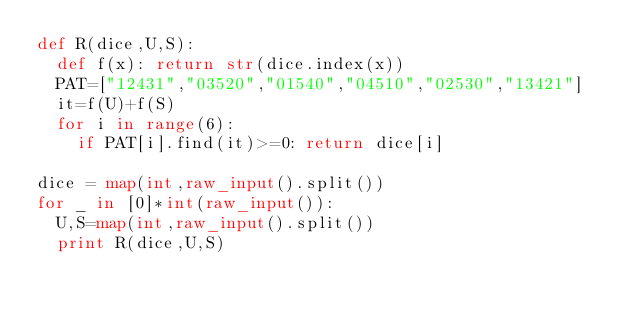<code> <loc_0><loc_0><loc_500><loc_500><_Python_>def R(dice,U,S):
  def f(x): return str(dice.index(x))
  PAT=["12431","03520","01540","04510","02530","13421"]
  it=f(U)+f(S)
  for i in range(6):
    if PAT[i].find(it)>=0: return dice[i]

dice = map(int,raw_input().split())
for _ in [0]*int(raw_input()):
  U,S=map(int,raw_input().split())
  print R(dice,U,S)</code> 